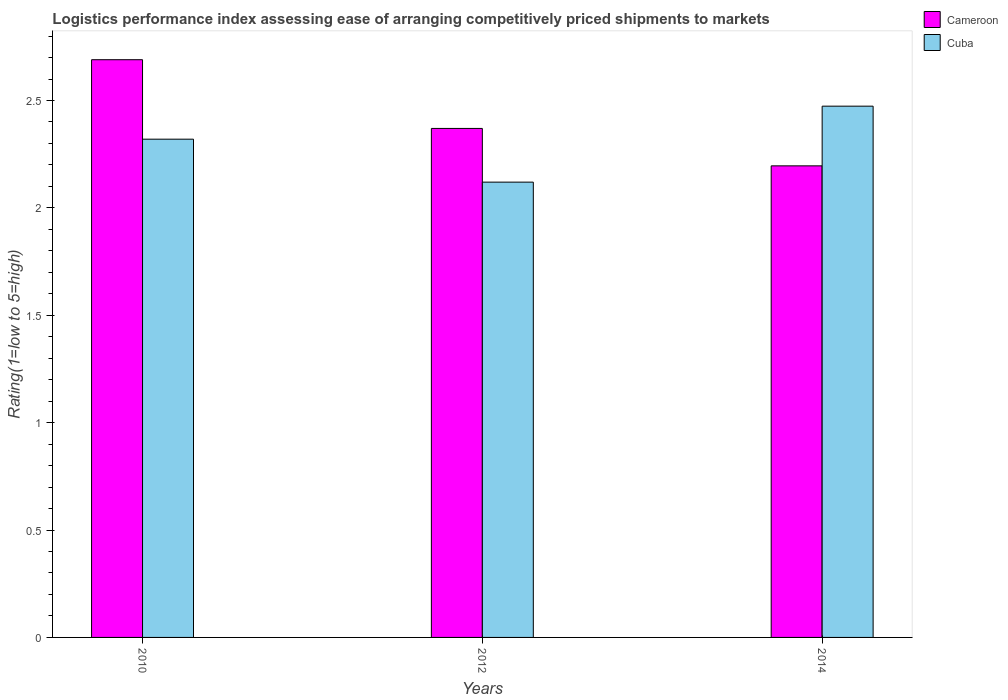How many different coloured bars are there?
Give a very brief answer. 2. How many groups of bars are there?
Provide a short and direct response. 3. What is the Logistic performance index in Cameroon in 2010?
Provide a succinct answer. 2.69. Across all years, what is the maximum Logistic performance index in Cuba?
Your answer should be compact. 2.47. Across all years, what is the minimum Logistic performance index in Cameroon?
Provide a succinct answer. 2.2. In which year was the Logistic performance index in Cameroon maximum?
Provide a succinct answer. 2010. What is the total Logistic performance index in Cuba in the graph?
Provide a short and direct response. 6.91. What is the difference between the Logistic performance index in Cuba in 2010 and that in 2014?
Make the answer very short. -0.15. What is the difference between the Logistic performance index in Cuba in 2010 and the Logistic performance index in Cameroon in 2012?
Your response must be concise. -0.05. What is the average Logistic performance index in Cuba per year?
Offer a very short reply. 2.3. In the year 2014, what is the difference between the Logistic performance index in Cameroon and Logistic performance index in Cuba?
Keep it short and to the point. -0.28. In how many years, is the Logistic performance index in Cameroon greater than 2.2?
Your answer should be compact. 2. What is the ratio of the Logistic performance index in Cuba in 2012 to that in 2014?
Keep it short and to the point. 0.86. Is the Logistic performance index in Cuba in 2010 less than that in 2014?
Keep it short and to the point. Yes. Is the difference between the Logistic performance index in Cameroon in 2010 and 2014 greater than the difference between the Logistic performance index in Cuba in 2010 and 2014?
Ensure brevity in your answer.  Yes. What is the difference between the highest and the second highest Logistic performance index in Cuba?
Give a very brief answer. 0.15. What is the difference between the highest and the lowest Logistic performance index in Cuba?
Provide a succinct answer. 0.35. Is the sum of the Logistic performance index in Cameroon in 2010 and 2012 greater than the maximum Logistic performance index in Cuba across all years?
Your answer should be compact. Yes. What does the 1st bar from the left in 2012 represents?
Make the answer very short. Cameroon. What does the 1st bar from the right in 2010 represents?
Give a very brief answer. Cuba. What is the difference between two consecutive major ticks on the Y-axis?
Your response must be concise. 0.5. Are the values on the major ticks of Y-axis written in scientific E-notation?
Provide a short and direct response. No. What is the title of the graph?
Provide a short and direct response. Logistics performance index assessing ease of arranging competitively priced shipments to markets. Does "Heavily indebted poor countries" appear as one of the legend labels in the graph?
Ensure brevity in your answer.  No. What is the label or title of the Y-axis?
Ensure brevity in your answer.  Rating(1=low to 5=high). What is the Rating(1=low to 5=high) in Cameroon in 2010?
Offer a very short reply. 2.69. What is the Rating(1=low to 5=high) of Cuba in 2010?
Offer a terse response. 2.32. What is the Rating(1=low to 5=high) of Cameroon in 2012?
Your response must be concise. 2.37. What is the Rating(1=low to 5=high) in Cuba in 2012?
Your response must be concise. 2.12. What is the Rating(1=low to 5=high) in Cameroon in 2014?
Your response must be concise. 2.2. What is the Rating(1=low to 5=high) of Cuba in 2014?
Offer a terse response. 2.47. Across all years, what is the maximum Rating(1=low to 5=high) in Cameroon?
Offer a terse response. 2.69. Across all years, what is the maximum Rating(1=low to 5=high) of Cuba?
Provide a short and direct response. 2.47. Across all years, what is the minimum Rating(1=low to 5=high) in Cameroon?
Ensure brevity in your answer.  2.2. Across all years, what is the minimum Rating(1=low to 5=high) of Cuba?
Provide a short and direct response. 2.12. What is the total Rating(1=low to 5=high) of Cameroon in the graph?
Keep it short and to the point. 7.26. What is the total Rating(1=low to 5=high) in Cuba in the graph?
Give a very brief answer. 6.91. What is the difference between the Rating(1=low to 5=high) in Cameroon in 2010 and that in 2012?
Provide a succinct answer. 0.32. What is the difference between the Rating(1=low to 5=high) in Cameroon in 2010 and that in 2014?
Your response must be concise. 0.49. What is the difference between the Rating(1=low to 5=high) of Cuba in 2010 and that in 2014?
Ensure brevity in your answer.  -0.15. What is the difference between the Rating(1=low to 5=high) in Cameroon in 2012 and that in 2014?
Offer a terse response. 0.17. What is the difference between the Rating(1=low to 5=high) of Cuba in 2012 and that in 2014?
Provide a succinct answer. -0.35. What is the difference between the Rating(1=low to 5=high) of Cameroon in 2010 and the Rating(1=low to 5=high) of Cuba in 2012?
Your answer should be compact. 0.57. What is the difference between the Rating(1=low to 5=high) of Cameroon in 2010 and the Rating(1=low to 5=high) of Cuba in 2014?
Make the answer very short. 0.22. What is the difference between the Rating(1=low to 5=high) of Cameroon in 2012 and the Rating(1=low to 5=high) of Cuba in 2014?
Provide a succinct answer. -0.1. What is the average Rating(1=low to 5=high) in Cameroon per year?
Offer a terse response. 2.42. What is the average Rating(1=low to 5=high) of Cuba per year?
Give a very brief answer. 2.3. In the year 2010, what is the difference between the Rating(1=low to 5=high) in Cameroon and Rating(1=low to 5=high) in Cuba?
Offer a terse response. 0.37. In the year 2014, what is the difference between the Rating(1=low to 5=high) of Cameroon and Rating(1=low to 5=high) of Cuba?
Your response must be concise. -0.28. What is the ratio of the Rating(1=low to 5=high) of Cameroon in 2010 to that in 2012?
Your answer should be very brief. 1.14. What is the ratio of the Rating(1=low to 5=high) in Cuba in 2010 to that in 2012?
Your answer should be compact. 1.09. What is the ratio of the Rating(1=low to 5=high) in Cameroon in 2010 to that in 2014?
Make the answer very short. 1.23. What is the ratio of the Rating(1=low to 5=high) in Cuba in 2010 to that in 2014?
Offer a terse response. 0.94. What is the ratio of the Rating(1=low to 5=high) of Cameroon in 2012 to that in 2014?
Your answer should be very brief. 1.08. What is the ratio of the Rating(1=low to 5=high) in Cuba in 2012 to that in 2014?
Offer a terse response. 0.86. What is the difference between the highest and the second highest Rating(1=low to 5=high) in Cameroon?
Your answer should be compact. 0.32. What is the difference between the highest and the second highest Rating(1=low to 5=high) of Cuba?
Keep it short and to the point. 0.15. What is the difference between the highest and the lowest Rating(1=low to 5=high) of Cameroon?
Your answer should be compact. 0.49. What is the difference between the highest and the lowest Rating(1=low to 5=high) of Cuba?
Your response must be concise. 0.35. 